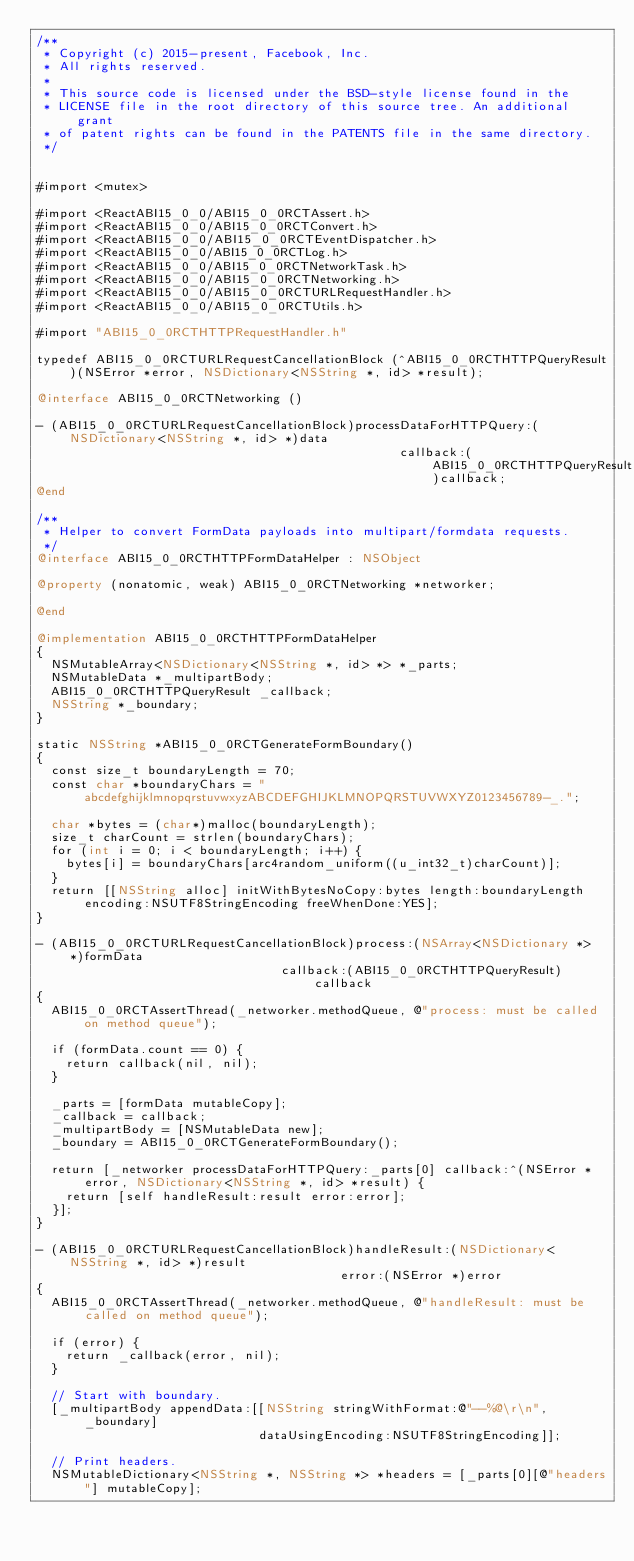Convert code to text. <code><loc_0><loc_0><loc_500><loc_500><_ObjectiveC_>/**
 * Copyright (c) 2015-present, Facebook, Inc.
 * All rights reserved.
 *
 * This source code is licensed under the BSD-style license found in the
 * LICENSE file in the root directory of this source tree. An additional grant
 * of patent rights can be found in the PATENTS file in the same directory.
 */


#import <mutex>

#import <ReactABI15_0_0/ABI15_0_0RCTAssert.h>
#import <ReactABI15_0_0/ABI15_0_0RCTConvert.h>
#import <ReactABI15_0_0/ABI15_0_0RCTEventDispatcher.h>
#import <ReactABI15_0_0/ABI15_0_0RCTLog.h>
#import <ReactABI15_0_0/ABI15_0_0RCTNetworkTask.h>
#import <ReactABI15_0_0/ABI15_0_0RCTNetworking.h>
#import <ReactABI15_0_0/ABI15_0_0RCTURLRequestHandler.h>
#import <ReactABI15_0_0/ABI15_0_0RCTUtils.h>

#import "ABI15_0_0RCTHTTPRequestHandler.h"

typedef ABI15_0_0RCTURLRequestCancellationBlock (^ABI15_0_0RCTHTTPQueryResult)(NSError *error, NSDictionary<NSString *, id> *result);

@interface ABI15_0_0RCTNetworking ()

- (ABI15_0_0RCTURLRequestCancellationBlock)processDataForHTTPQuery:(NSDictionary<NSString *, id> *)data
                                                 callback:(ABI15_0_0RCTHTTPQueryResult)callback;
@end

/**
 * Helper to convert FormData payloads into multipart/formdata requests.
 */
@interface ABI15_0_0RCTHTTPFormDataHelper : NSObject

@property (nonatomic, weak) ABI15_0_0RCTNetworking *networker;

@end

@implementation ABI15_0_0RCTHTTPFormDataHelper
{
  NSMutableArray<NSDictionary<NSString *, id> *> *_parts;
  NSMutableData *_multipartBody;
  ABI15_0_0RCTHTTPQueryResult _callback;
  NSString *_boundary;
}

static NSString *ABI15_0_0RCTGenerateFormBoundary()
{
  const size_t boundaryLength = 70;
  const char *boundaryChars = "abcdefghijklmnopqrstuvwxyzABCDEFGHIJKLMNOPQRSTUVWXYZ0123456789-_.";

  char *bytes = (char*)malloc(boundaryLength);
  size_t charCount = strlen(boundaryChars);
  for (int i = 0; i < boundaryLength; i++) {
    bytes[i] = boundaryChars[arc4random_uniform((u_int32_t)charCount)];
  }
  return [[NSString alloc] initWithBytesNoCopy:bytes length:boundaryLength encoding:NSUTF8StringEncoding freeWhenDone:YES];
}

- (ABI15_0_0RCTURLRequestCancellationBlock)process:(NSArray<NSDictionary *> *)formData
                                 callback:(ABI15_0_0RCTHTTPQueryResult)callback
{
  ABI15_0_0RCTAssertThread(_networker.methodQueue, @"process: must be called on method queue");

  if (formData.count == 0) {
    return callback(nil, nil);
  }

  _parts = [formData mutableCopy];
  _callback = callback;
  _multipartBody = [NSMutableData new];
  _boundary = ABI15_0_0RCTGenerateFormBoundary();

  return [_networker processDataForHTTPQuery:_parts[0] callback:^(NSError *error, NSDictionary<NSString *, id> *result) {
    return [self handleResult:result error:error];
  }];
}

- (ABI15_0_0RCTURLRequestCancellationBlock)handleResult:(NSDictionary<NSString *, id> *)result
                                         error:(NSError *)error
{
  ABI15_0_0RCTAssertThread(_networker.methodQueue, @"handleResult: must be called on method queue");

  if (error) {
    return _callback(error, nil);
  }

  // Start with boundary.
  [_multipartBody appendData:[[NSString stringWithFormat:@"--%@\r\n", _boundary]
                              dataUsingEncoding:NSUTF8StringEncoding]];

  // Print headers.
  NSMutableDictionary<NSString *, NSString *> *headers = [_parts[0][@"headers"] mutableCopy];</code> 